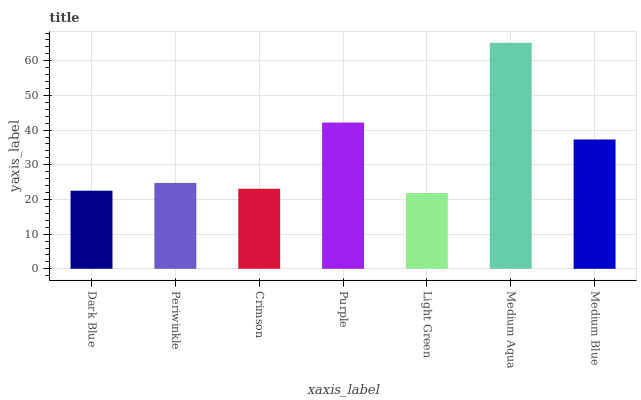Is Light Green the minimum?
Answer yes or no. Yes. Is Medium Aqua the maximum?
Answer yes or no. Yes. Is Periwinkle the minimum?
Answer yes or no. No. Is Periwinkle the maximum?
Answer yes or no. No. Is Periwinkle greater than Dark Blue?
Answer yes or no. Yes. Is Dark Blue less than Periwinkle?
Answer yes or no. Yes. Is Dark Blue greater than Periwinkle?
Answer yes or no. No. Is Periwinkle less than Dark Blue?
Answer yes or no. No. Is Periwinkle the high median?
Answer yes or no. Yes. Is Periwinkle the low median?
Answer yes or no. Yes. Is Dark Blue the high median?
Answer yes or no. No. Is Purple the low median?
Answer yes or no. No. 